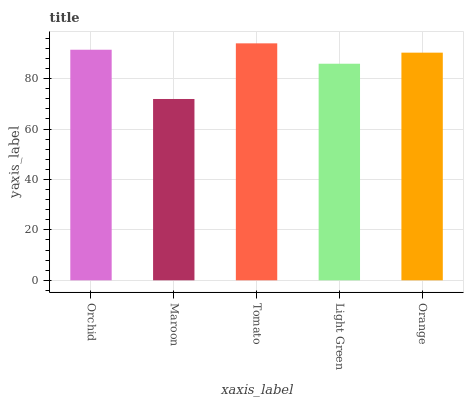Is Maroon the minimum?
Answer yes or no. Yes. Is Tomato the maximum?
Answer yes or no. Yes. Is Tomato the minimum?
Answer yes or no. No. Is Maroon the maximum?
Answer yes or no. No. Is Tomato greater than Maroon?
Answer yes or no. Yes. Is Maroon less than Tomato?
Answer yes or no. Yes. Is Maroon greater than Tomato?
Answer yes or no. No. Is Tomato less than Maroon?
Answer yes or no. No. Is Orange the high median?
Answer yes or no. Yes. Is Orange the low median?
Answer yes or no. Yes. Is Orchid the high median?
Answer yes or no. No. Is Orchid the low median?
Answer yes or no. No. 